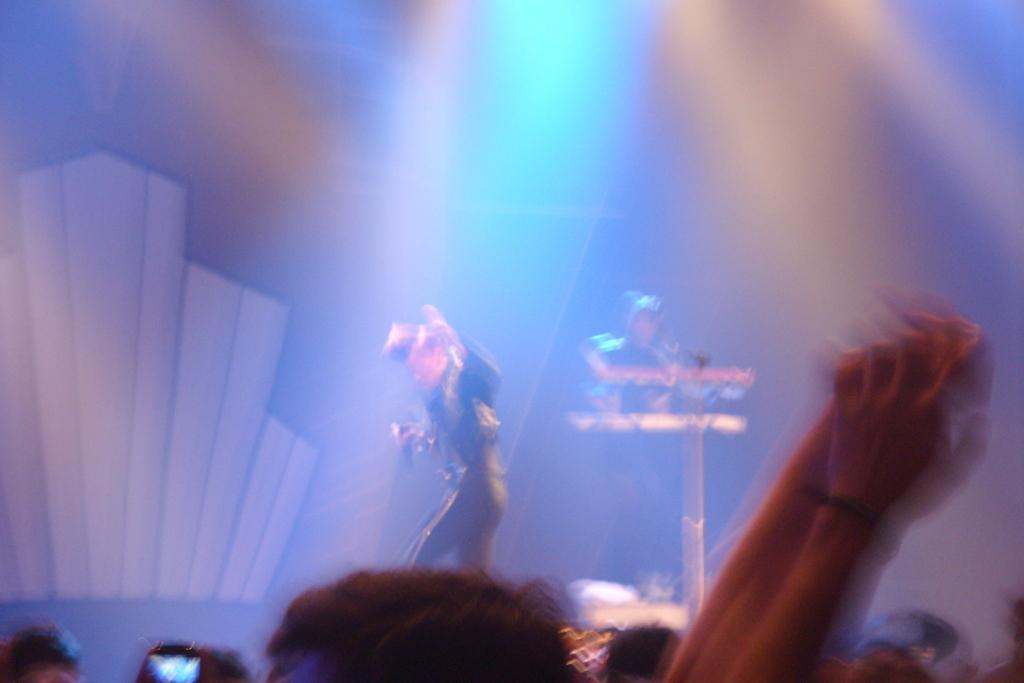Could you give a brief overview of what you see in this image? In this picture there is a person wearing black dress is standing and holding a mic in his hand and there is another person behind him and there are few audience in front of them. 